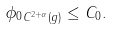Convert formula to latex. <formula><loc_0><loc_0><loc_500><loc_500>\| \phi _ { 0 } \| _ { C ^ { 2 + \alpha } ( g ) } \leq C _ { 0 } .</formula> 